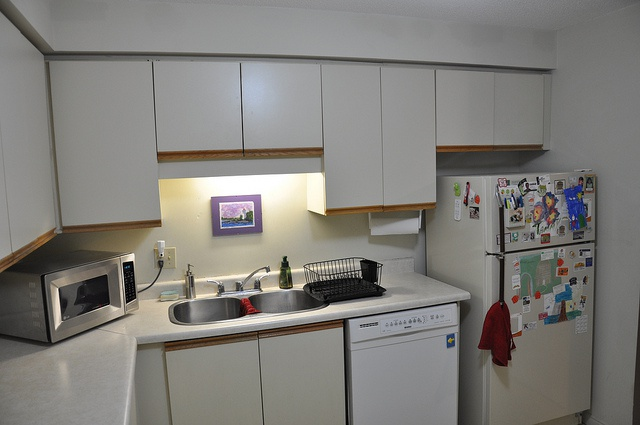Describe the objects in this image and their specific colors. I can see refrigerator in black and gray tones, microwave in black, gray, and darkgray tones, sink in black and gray tones, and bottle in black, darkgreen, and gray tones in this image. 